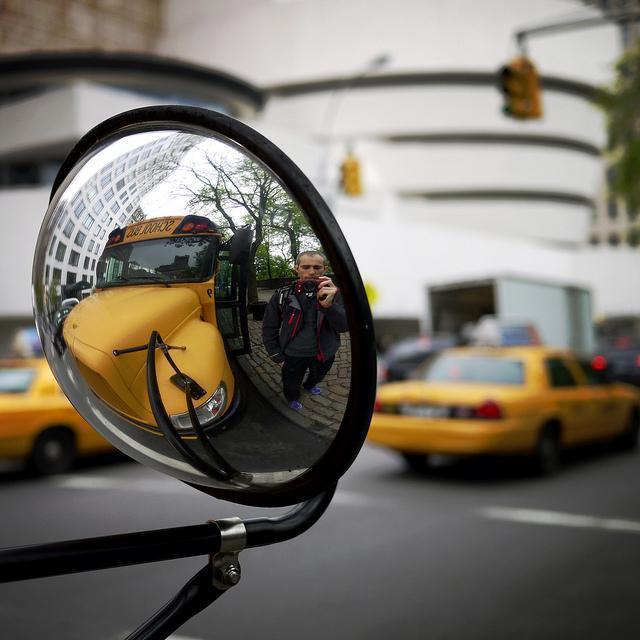How many taxi cabs are in the picture?
Give a very brief answer. 2. How many things are yellow?
Give a very brief answer. 3. How many cars are visible?
Give a very brief answer. 4. How many skateboard wheels can you see?
Give a very brief answer. 0. 